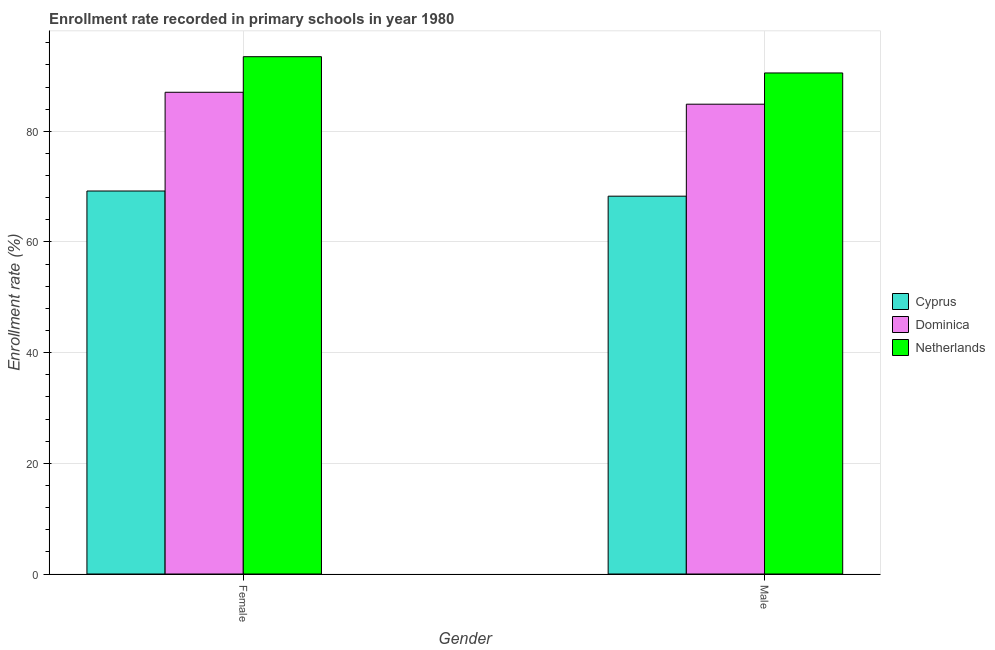How many different coloured bars are there?
Give a very brief answer. 3. How many groups of bars are there?
Keep it short and to the point. 2. Are the number of bars per tick equal to the number of legend labels?
Your answer should be compact. Yes. How many bars are there on the 1st tick from the right?
Provide a short and direct response. 3. What is the label of the 1st group of bars from the left?
Ensure brevity in your answer.  Female. What is the enrollment rate of male students in Netherlands?
Offer a terse response. 90.55. Across all countries, what is the maximum enrollment rate of male students?
Give a very brief answer. 90.55. Across all countries, what is the minimum enrollment rate of female students?
Give a very brief answer. 69.22. In which country was the enrollment rate of female students maximum?
Offer a terse response. Netherlands. In which country was the enrollment rate of female students minimum?
Your answer should be very brief. Cyprus. What is the total enrollment rate of male students in the graph?
Your answer should be compact. 243.73. What is the difference between the enrollment rate of male students in Netherlands and that in Cyprus?
Your answer should be very brief. 22.27. What is the difference between the enrollment rate of female students in Netherlands and the enrollment rate of male students in Cyprus?
Offer a very short reply. 25.21. What is the average enrollment rate of female students per country?
Your response must be concise. 83.25. What is the difference between the enrollment rate of female students and enrollment rate of male students in Dominica?
Keep it short and to the point. 2.16. In how many countries, is the enrollment rate of female students greater than 44 %?
Your answer should be very brief. 3. What is the ratio of the enrollment rate of female students in Netherlands to that in Cyprus?
Offer a terse response. 1.35. In how many countries, is the enrollment rate of male students greater than the average enrollment rate of male students taken over all countries?
Offer a terse response. 2. What does the 2nd bar from the left in Male represents?
Offer a terse response. Dominica. What does the 3rd bar from the right in Female represents?
Your answer should be compact. Cyprus. Does the graph contain any zero values?
Offer a very short reply. No. Does the graph contain grids?
Offer a very short reply. Yes. Where does the legend appear in the graph?
Provide a short and direct response. Center right. How many legend labels are there?
Give a very brief answer. 3. What is the title of the graph?
Ensure brevity in your answer.  Enrollment rate recorded in primary schools in year 1980. Does "Kazakhstan" appear as one of the legend labels in the graph?
Your response must be concise. No. What is the label or title of the X-axis?
Give a very brief answer. Gender. What is the label or title of the Y-axis?
Your response must be concise. Enrollment rate (%). What is the Enrollment rate (%) in Cyprus in Female?
Provide a short and direct response. 69.22. What is the Enrollment rate (%) in Dominica in Female?
Make the answer very short. 87.06. What is the Enrollment rate (%) of Netherlands in Female?
Give a very brief answer. 93.49. What is the Enrollment rate (%) in Cyprus in Male?
Offer a terse response. 68.28. What is the Enrollment rate (%) of Dominica in Male?
Your response must be concise. 84.9. What is the Enrollment rate (%) of Netherlands in Male?
Make the answer very short. 90.55. Across all Gender, what is the maximum Enrollment rate (%) of Cyprus?
Your response must be concise. 69.22. Across all Gender, what is the maximum Enrollment rate (%) in Dominica?
Make the answer very short. 87.06. Across all Gender, what is the maximum Enrollment rate (%) in Netherlands?
Your response must be concise. 93.49. Across all Gender, what is the minimum Enrollment rate (%) in Cyprus?
Your answer should be compact. 68.28. Across all Gender, what is the minimum Enrollment rate (%) in Dominica?
Provide a succinct answer. 84.9. Across all Gender, what is the minimum Enrollment rate (%) in Netherlands?
Provide a succinct answer. 90.55. What is the total Enrollment rate (%) of Cyprus in the graph?
Provide a succinct answer. 137.49. What is the total Enrollment rate (%) in Dominica in the graph?
Offer a terse response. 171.96. What is the total Enrollment rate (%) of Netherlands in the graph?
Your answer should be compact. 184.04. What is the difference between the Enrollment rate (%) in Cyprus in Female and that in Male?
Keep it short and to the point. 0.94. What is the difference between the Enrollment rate (%) in Dominica in Female and that in Male?
Your answer should be compact. 2.16. What is the difference between the Enrollment rate (%) in Netherlands in Female and that in Male?
Your answer should be compact. 2.94. What is the difference between the Enrollment rate (%) of Cyprus in Female and the Enrollment rate (%) of Dominica in Male?
Make the answer very short. -15.69. What is the difference between the Enrollment rate (%) of Cyprus in Female and the Enrollment rate (%) of Netherlands in Male?
Your answer should be very brief. -21.33. What is the difference between the Enrollment rate (%) of Dominica in Female and the Enrollment rate (%) of Netherlands in Male?
Your response must be concise. -3.49. What is the average Enrollment rate (%) of Cyprus per Gender?
Offer a terse response. 68.75. What is the average Enrollment rate (%) in Dominica per Gender?
Your answer should be very brief. 85.98. What is the average Enrollment rate (%) in Netherlands per Gender?
Your response must be concise. 92.02. What is the difference between the Enrollment rate (%) of Cyprus and Enrollment rate (%) of Dominica in Female?
Provide a succinct answer. -17.84. What is the difference between the Enrollment rate (%) in Cyprus and Enrollment rate (%) in Netherlands in Female?
Your answer should be very brief. -24.27. What is the difference between the Enrollment rate (%) in Dominica and Enrollment rate (%) in Netherlands in Female?
Your answer should be compact. -6.43. What is the difference between the Enrollment rate (%) of Cyprus and Enrollment rate (%) of Dominica in Male?
Your answer should be compact. -16.62. What is the difference between the Enrollment rate (%) of Cyprus and Enrollment rate (%) of Netherlands in Male?
Ensure brevity in your answer.  -22.27. What is the difference between the Enrollment rate (%) in Dominica and Enrollment rate (%) in Netherlands in Male?
Your response must be concise. -5.64. What is the ratio of the Enrollment rate (%) of Cyprus in Female to that in Male?
Ensure brevity in your answer.  1.01. What is the ratio of the Enrollment rate (%) of Dominica in Female to that in Male?
Provide a succinct answer. 1.03. What is the ratio of the Enrollment rate (%) in Netherlands in Female to that in Male?
Offer a terse response. 1.03. What is the difference between the highest and the second highest Enrollment rate (%) in Cyprus?
Your response must be concise. 0.94. What is the difference between the highest and the second highest Enrollment rate (%) in Dominica?
Your response must be concise. 2.16. What is the difference between the highest and the second highest Enrollment rate (%) in Netherlands?
Provide a succinct answer. 2.94. What is the difference between the highest and the lowest Enrollment rate (%) of Cyprus?
Your answer should be very brief. 0.94. What is the difference between the highest and the lowest Enrollment rate (%) in Dominica?
Provide a short and direct response. 2.16. What is the difference between the highest and the lowest Enrollment rate (%) in Netherlands?
Your answer should be very brief. 2.94. 